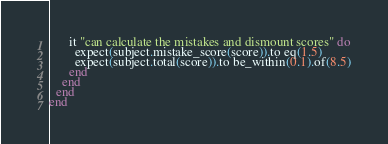<code> <loc_0><loc_0><loc_500><loc_500><_Ruby_>
      it "can calculate the mistakes and dismount scores" do
        expect(subject.mistake_score(score)).to eq(1.5)
        expect(subject.total(score)).to be_within(0.1).of(8.5)
      end
    end
  end
end
</code> 